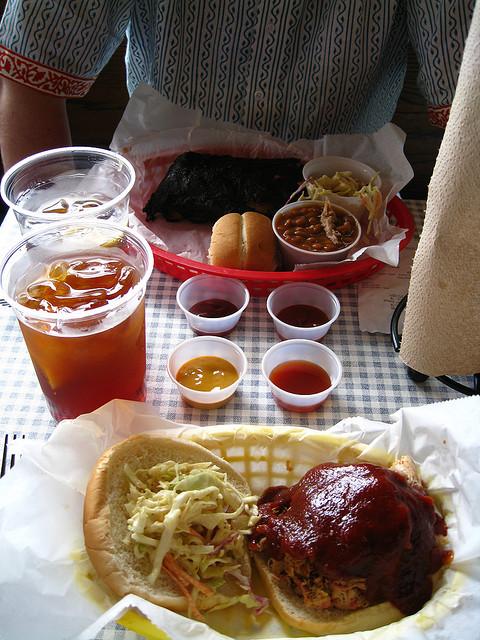What color is the tablecloth?
Answer briefly. Blue and white. Is the basket edible?
Concise answer only. No. Is this diner food?
Write a very short answer. Yes. 